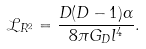Convert formula to latex. <formula><loc_0><loc_0><loc_500><loc_500>\mathcal { L } _ { R ^ { 2 } } = \frac { D ( D - 1 ) \alpha } { 8 \pi G _ { D } l ^ { 4 } } .</formula> 